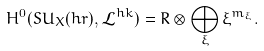Convert formula to latex. <formula><loc_0><loc_0><loc_500><loc_500>H ^ { 0 } ( S U _ { X } ( h r ) , \mathcal { L } ^ { h k } ) = R \otimes \bigoplus _ { \xi } \xi ^ { m _ { \xi } } .</formula> 